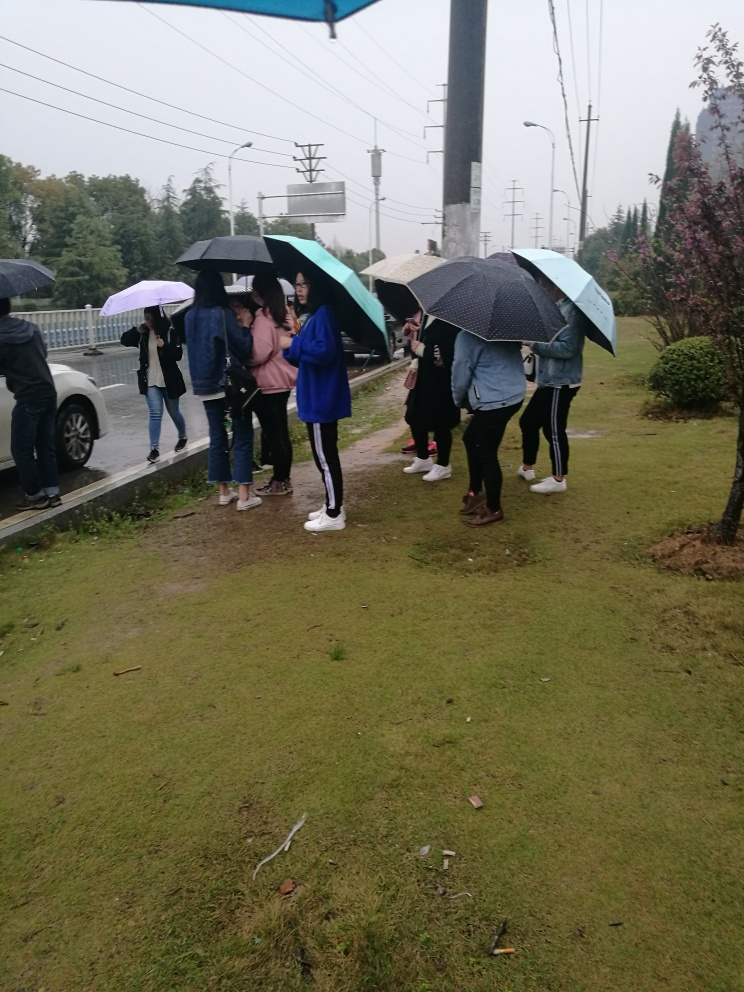What could be the reason for people to be outside with umbrellas? Are they waiting for something? Given the presence of umbrellas, it seems likely that it's raining or has been raining recently. The people appear to be standing on a sidewalk, which might indicate they are waiting for public transportation or perhaps for a ride. The group seems to be engaging in casual conversation as they wait. 